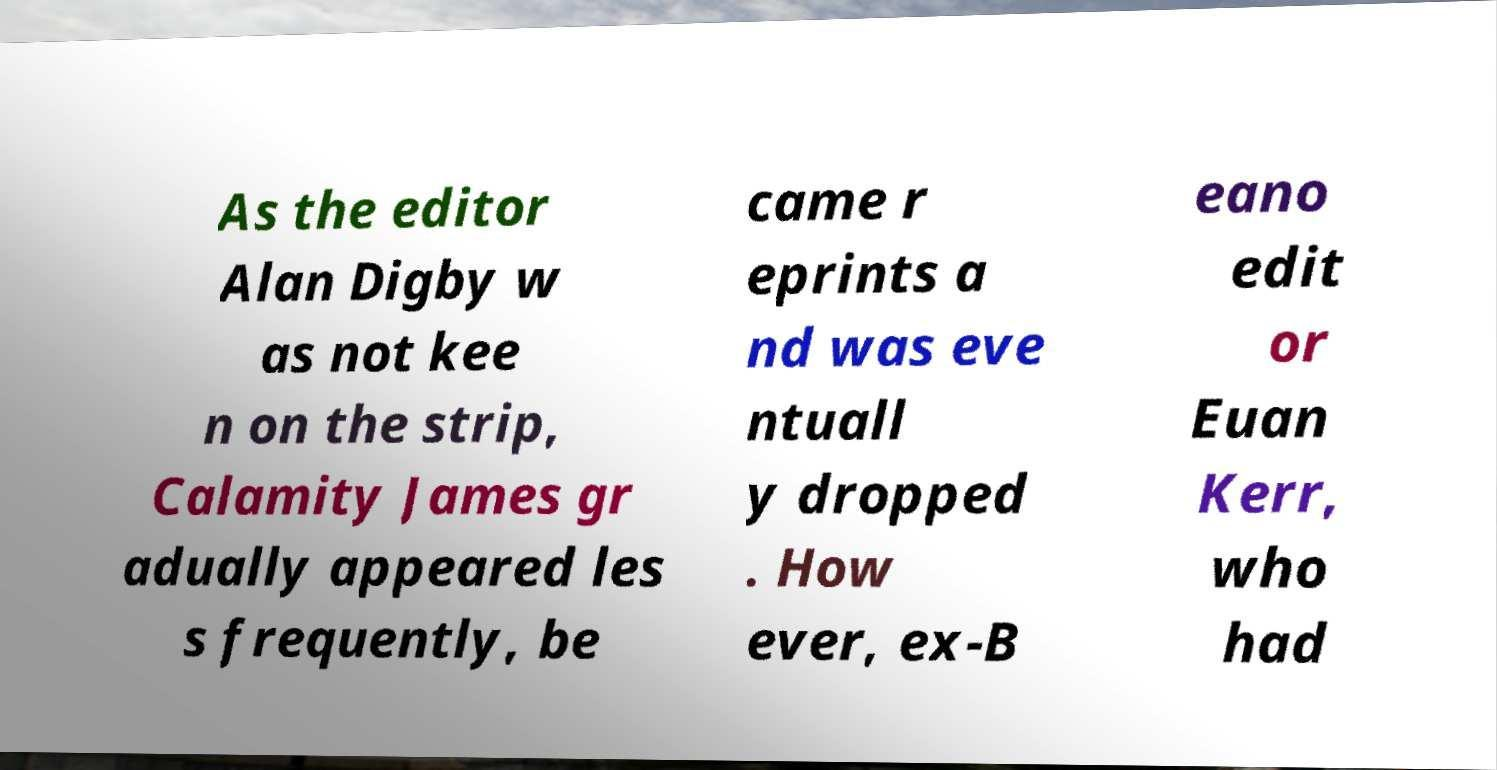Can you read and provide the text displayed in the image?This photo seems to have some interesting text. Can you extract and type it out for me? As the editor Alan Digby w as not kee n on the strip, Calamity James gr adually appeared les s frequently, be came r eprints a nd was eve ntuall y dropped . How ever, ex-B eano edit or Euan Kerr, who had 